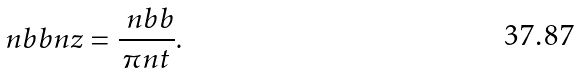<formula> <loc_0><loc_0><loc_500><loc_500>\ n b b n z = \frac { \ n b b } { \pi n t } .</formula> 